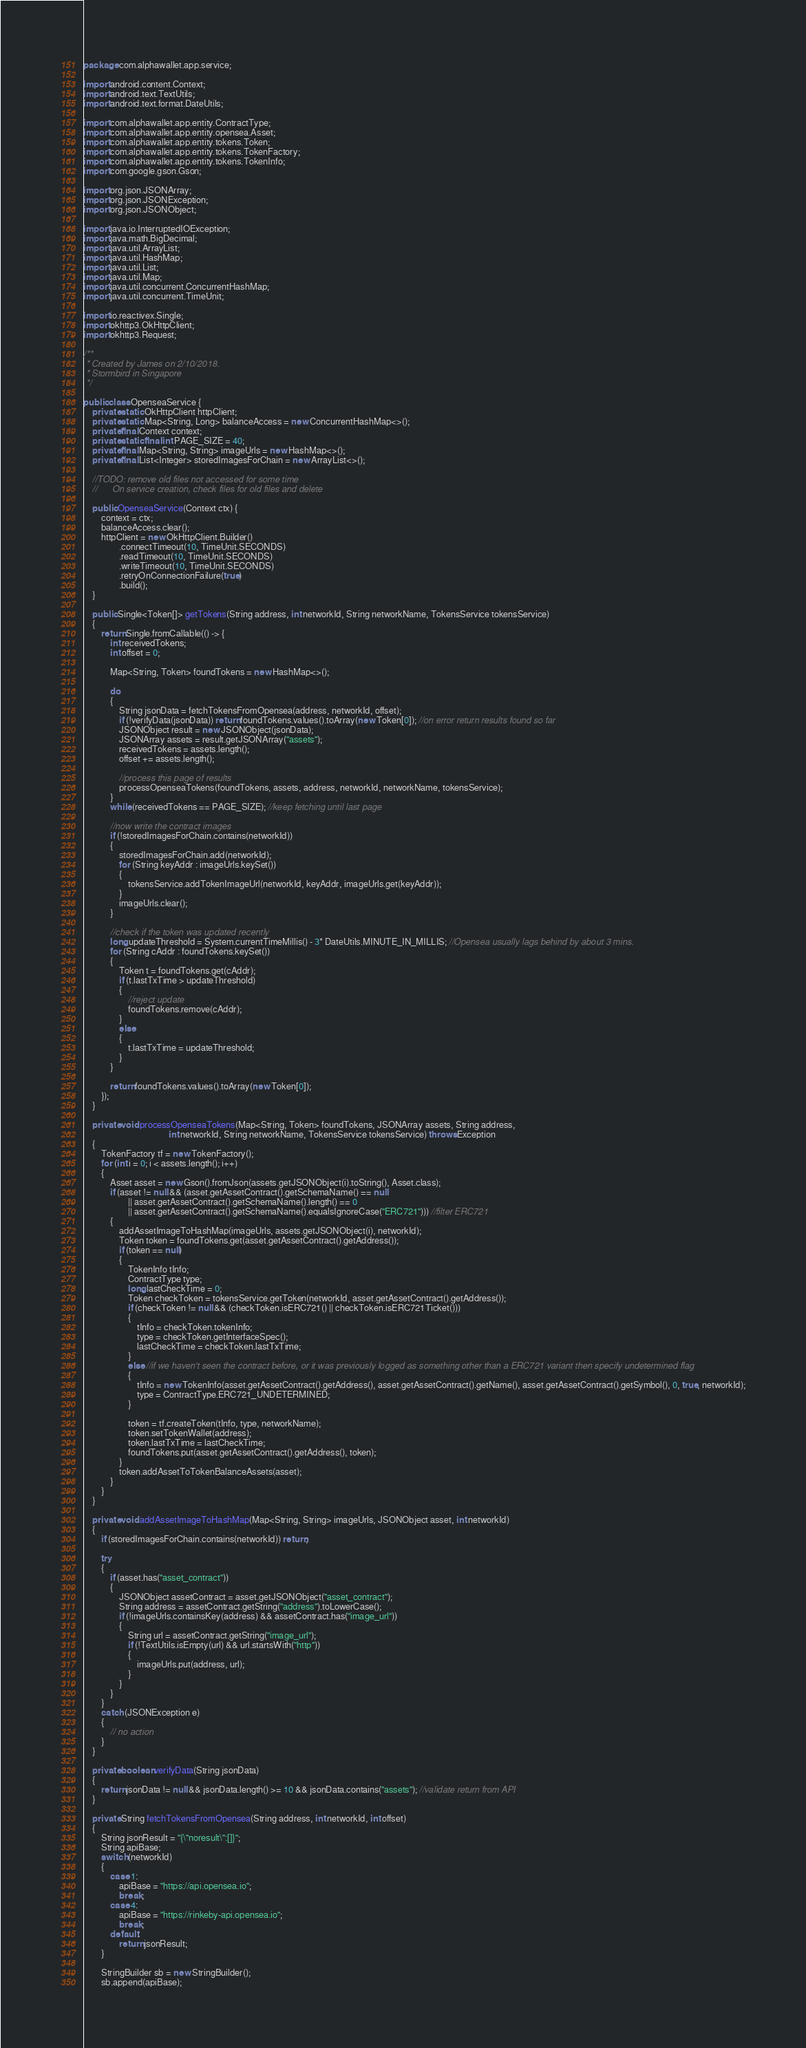<code> <loc_0><loc_0><loc_500><loc_500><_Java_>package com.alphawallet.app.service;

import android.content.Context;
import android.text.TextUtils;
import android.text.format.DateUtils;

import com.alphawallet.app.entity.ContractType;
import com.alphawallet.app.entity.opensea.Asset;
import com.alphawallet.app.entity.tokens.Token;
import com.alphawallet.app.entity.tokens.TokenFactory;
import com.alphawallet.app.entity.tokens.TokenInfo;
import com.google.gson.Gson;

import org.json.JSONArray;
import org.json.JSONException;
import org.json.JSONObject;

import java.io.InterruptedIOException;
import java.math.BigDecimal;
import java.util.ArrayList;
import java.util.HashMap;
import java.util.List;
import java.util.Map;
import java.util.concurrent.ConcurrentHashMap;
import java.util.concurrent.TimeUnit;

import io.reactivex.Single;
import okhttp3.OkHttpClient;
import okhttp3.Request;

/**
 * Created by James on 2/10/2018.
 * Stormbird in Singapore
 */

public class OpenseaService {
    private static OkHttpClient httpClient;
    private static Map<String, Long> balanceAccess = new ConcurrentHashMap<>();
    private final Context context;
    private static final int PAGE_SIZE = 40;
    private final Map<String, String> imageUrls = new HashMap<>();
    private final List<Integer> storedImagesForChain = new ArrayList<>();

    //TODO: remove old files not accessed for some time
    //      On service creation, check files for old files and delete

    public OpenseaService(Context ctx) {
        context = ctx;
        balanceAccess.clear();
        httpClient = new OkHttpClient.Builder()
                .connectTimeout(10, TimeUnit.SECONDS)
                .readTimeout(10, TimeUnit.SECONDS)
                .writeTimeout(10, TimeUnit.SECONDS)
                .retryOnConnectionFailure(true)
                .build();
    }

    public Single<Token[]> getTokens(String address, int networkId, String networkName, TokensService tokensService)
    {
        return Single.fromCallable(() -> {
            int receivedTokens;
            int offset = 0;

            Map<String, Token> foundTokens = new HashMap<>();

            do
            {
                String jsonData = fetchTokensFromOpensea(address, networkId, offset);
                if (!verifyData(jsonData)) return foundTokens.values().toArray(new Token[0]); //on error return results found so far
                JSONObject result = new JSONObject(jsonData);
                JSONArray assets = result.getJSONArray("assets");
                receivedTokens = assets.length();
                offset += assets.length();

                //process this page of results
                processOpenseaTokens(foundTokens, assets, address, networkId, networkName, tokensService);
            }
            while (receivedTokens == PAGE_SIZE); //keep fetching until last page

            //now write the contract images
            if (!storedImagesForChain.contains(networkId))
            {
                storedImagesForChain.add(networkId);
                for (String keyAddr : imageUrls.keySet())
                {
                    tokensService.addTokenImageUrl(networkId, keyAddr, imageUrls.get(keyAddr));
                }
                imageUrls.clear();
            }

            //check if the token was updated recently
            long updateThreshold = System.currentTimeMillis() - 3* DateUtils.MINUTE_IN_MILLIS; //Opensea usually lags behind by about 3 mins.
            for (String cAddr : foundTokens.keySet())
            {
                Token t = foundTokens.get(cAddr);
                if (t.lastTxTime > updateThreshold)
                {
                    //reject update
                    foundTokens.remove(cAddr);
                }
                else
                {
                    t.lastTxTime = updateThreshold;
                }
            }

            return foundTokens.values().toArray(new Token[0]);
        });
    }

    private void processOpenseaTokens(Map<String, Token> foundTokens, JSONArray assets, String address,
                                      int networkId, String networkName, TokensService tokensService) throws Exception
    {
        TokenFactory tf = new TokenFactory();
        for (int i = 0; i < assets.length(); i++)
        {
            Asset asset = new Gson().fromJson(assets.getJSONObject(i).toString(), Asset.class);
            if (asset != null && (asset.getAssetContract().getSchemaName() == null
                    || asset.getAssetContract().getSchemaName().length() == 0
                    || asset.getAssetContract().getSchemaName().equalsIgnoreCase("ERC721"))) //filter ERC721
            {
                addAssetImageToHashMap(imageUrls, assets.getJSONObject(i), networkId);
                Token token = foundTokens.get(asset.getAssetContract().getAddress());
                if (token == null)
                {
                    TokenInfo tInfo;
                    ContractType type;
                    long lastCheckTime = 0;
                    Token checkToken = tokensService.getToken(networkId, asset.getAssetContract().getAddress());
                    if (checkToken != null && (checkToken.isERC721() || checkToken.isERC721Ticket()))
                    {
                        tInfo = checkToken.tokenInfo;
                        type = checkToken.getInterfaceSpec();
                        lastCheckTime = checkToken.lastTxTime;
                    }
                    else //if we haven't seen the contract before, or it was previously logged as something other than a ERC721 variant then specify undetermined flag
                    {
                        tInfo = new TokenInfo(asset.getAssetContract().getAddress(), asset.getAssetContract().getName(), asset.getAssetContract().getSymbol(), 0, true, networkId);
                        type = ContractType.ERC721_UNDETERMINED;
                    }

                    token = tf.createToken(tInfo, type, networkName);
                    token.setTokenWallet(address);
                    token.lastTxTime = lastCheckTime;
                    foundTokens.put(asset.getAssetContract().getAddress(), token);
                }
                token.addAssetToTokenBalanceAssets(asset);
            }
        }
    }

    private void addAssetImageToHashMap(Map<String, String> imageUrls, JSONObject asset, int networkId)
    {
        if (storedImagesForChain.contains(networkId)) return;

        try
        {
            if (asset.has("asset_contract"))
            {
                JSONObject assetContract = asset.getJSONObject("asset_contract");
                String address = assetContract.getString("address").toLowerCase();
                if (!imageUrls.containsKey(address) && assetContract.has("image_url"))
                {
                    String url = assetContract.getString("image_url");
                    if (!TextUtils.isEmpty(url) && url.startsWith("http"))
                    {
                        imageUrls.put(address, url);
                    }
                }
            }
        }
        catch (JSONException e)
        {
            // no action
        }
    }

    private boolean verifyData(String jsonData)
    {
        return jsonData != null && jsonData.length() >= 10 && jsonData.contains("assets"); //validate return from API
    }

    private String fetchTokensFromOpensea(String address, int networkId, int offset)
    {
        String jsonResult = "{\"noresult\":[]}";
        String apiBase;
        switch (networkId)
        {
            case 1:
                apiBase = "https://api.opensea.io";
                break;
            case 4:
                apiBase = "https://rinkeby-api.opensea.io";
                break;
            default:
                return jsonResult;
        }

        StringBuilder sb = new StringBuilder();
        sb.append(apiBase);</code> 